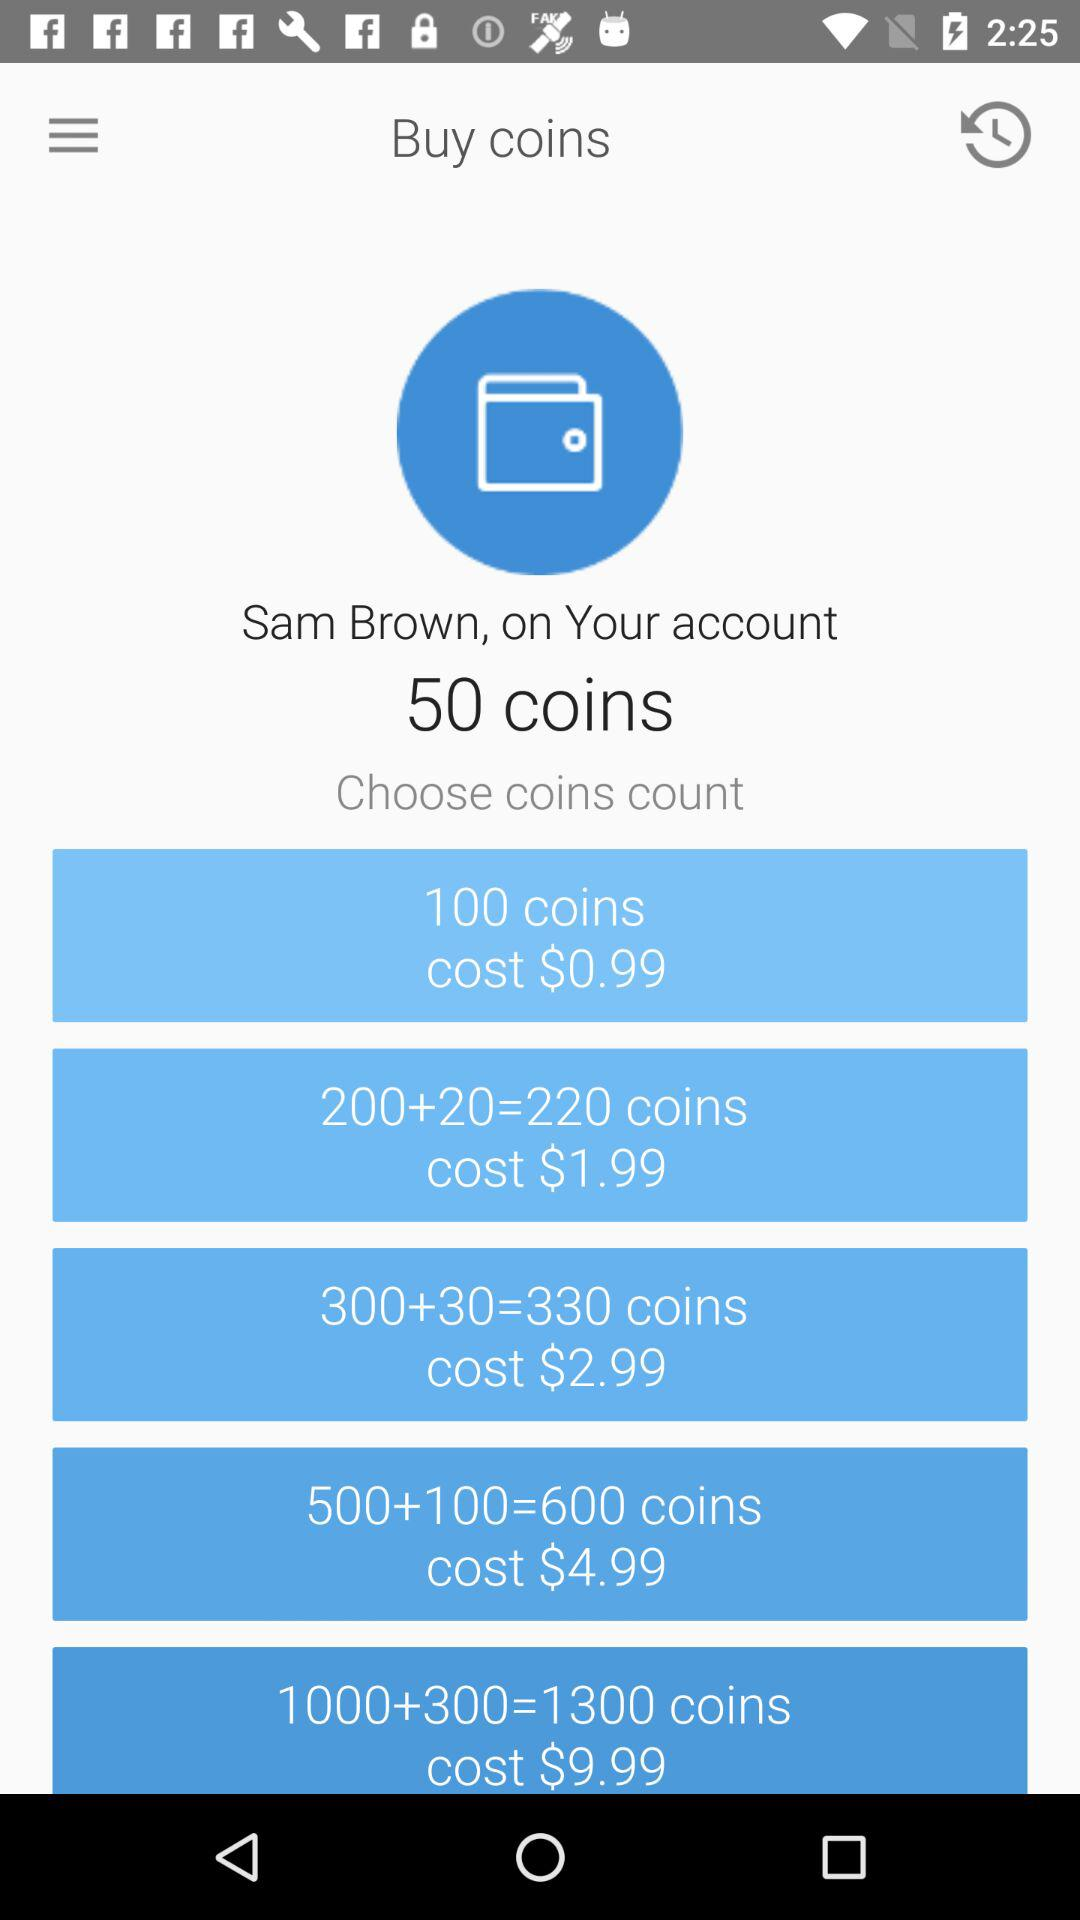How many coins does Sam Brown have? Sam Brown have 50 coins. 